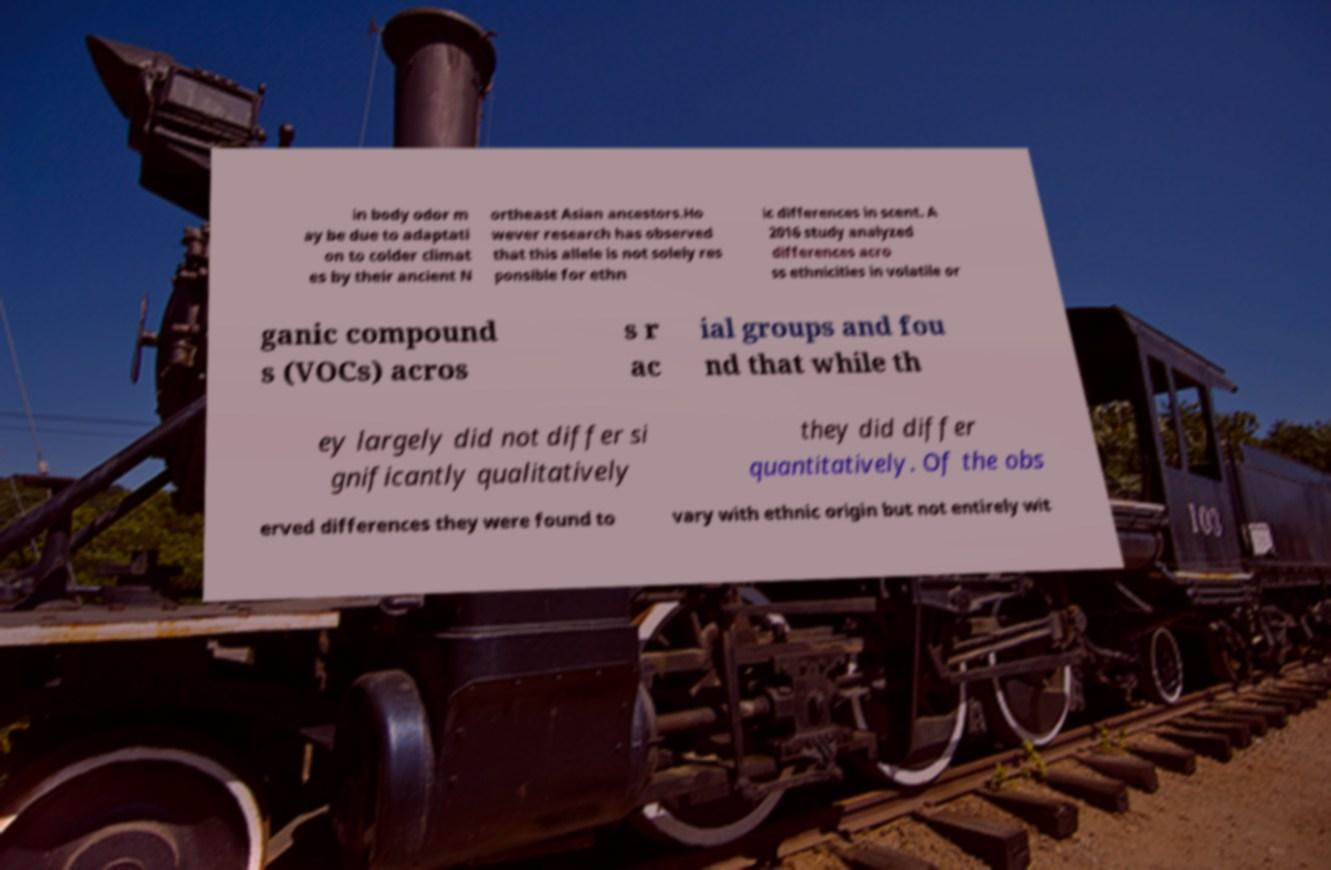Please read and relay the text visible in this image. What does it say? in body odor m ay be due to adaptati on to colder climat es by their ancient N ortheast Asian ancestors.Ho wever research has observed that this allele is not solely res ponsible for ethn ic differences in scent. A 2016 study analyzed differences acro ss ethnicities in volatile or ganic compound s (VOCs) acros s r ac ial groups and fou nd that while th ey largely did not differ si gnificantly qualitatively they did differ quantitatively. Of the obs erved differences they were found to vary with ethnic origin but not entirely wit 